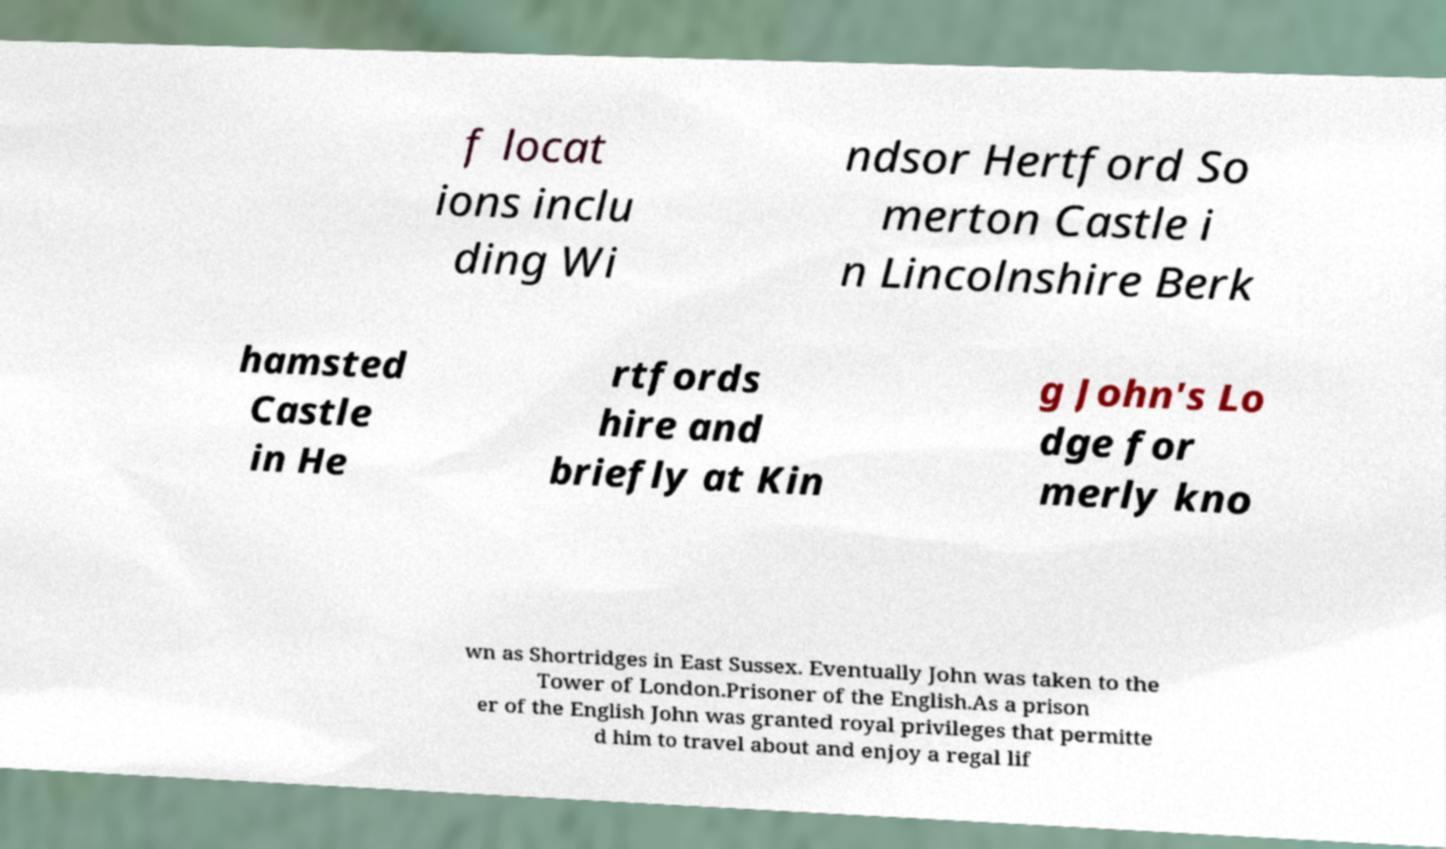Could you assist in decoding the text presented in this image and type it out clearly? f locat ions inclu ding Wi ndsor Hertford So merton Castle i n Lincolnshire Berk hamsted Castle in He rtfords hire and briefly at Kin g John's Lo dge for merly kno wn as Shortridges in East Sussex. Eventually John was taken to the Tower of London.Prisoner of the English.As a prison er of the English John was granted royal privileges that permitte d him to travel about and enjoy a regal lif 